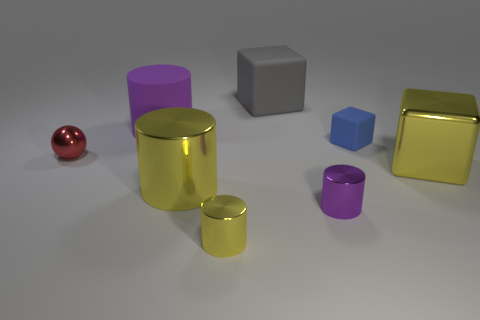Subtract all yellow blocks. How many blocks are left? 2 Subtract all purple cylinders. How many cylinders are left? 2 Subtract all cubes. How many objects are left? 5 Subtract 2 cylinders. How many cylinders are left? 2 Subtract all small shiny objects. Subtract all large cyan matte things. How many objects are left? 5 Add 2 red balls. How many red balls are left? 3 Add 6 large yellow metallic cubes. How many large yellow metallic cubes exist? 7 Add 2 big yellow rubber blocks. How many objects exist? 10 Subtract 0 purple blocks. How many objects are left? 8 Subtract all green cubes. Subtract all purple spheres. How many cubes are left? 3 